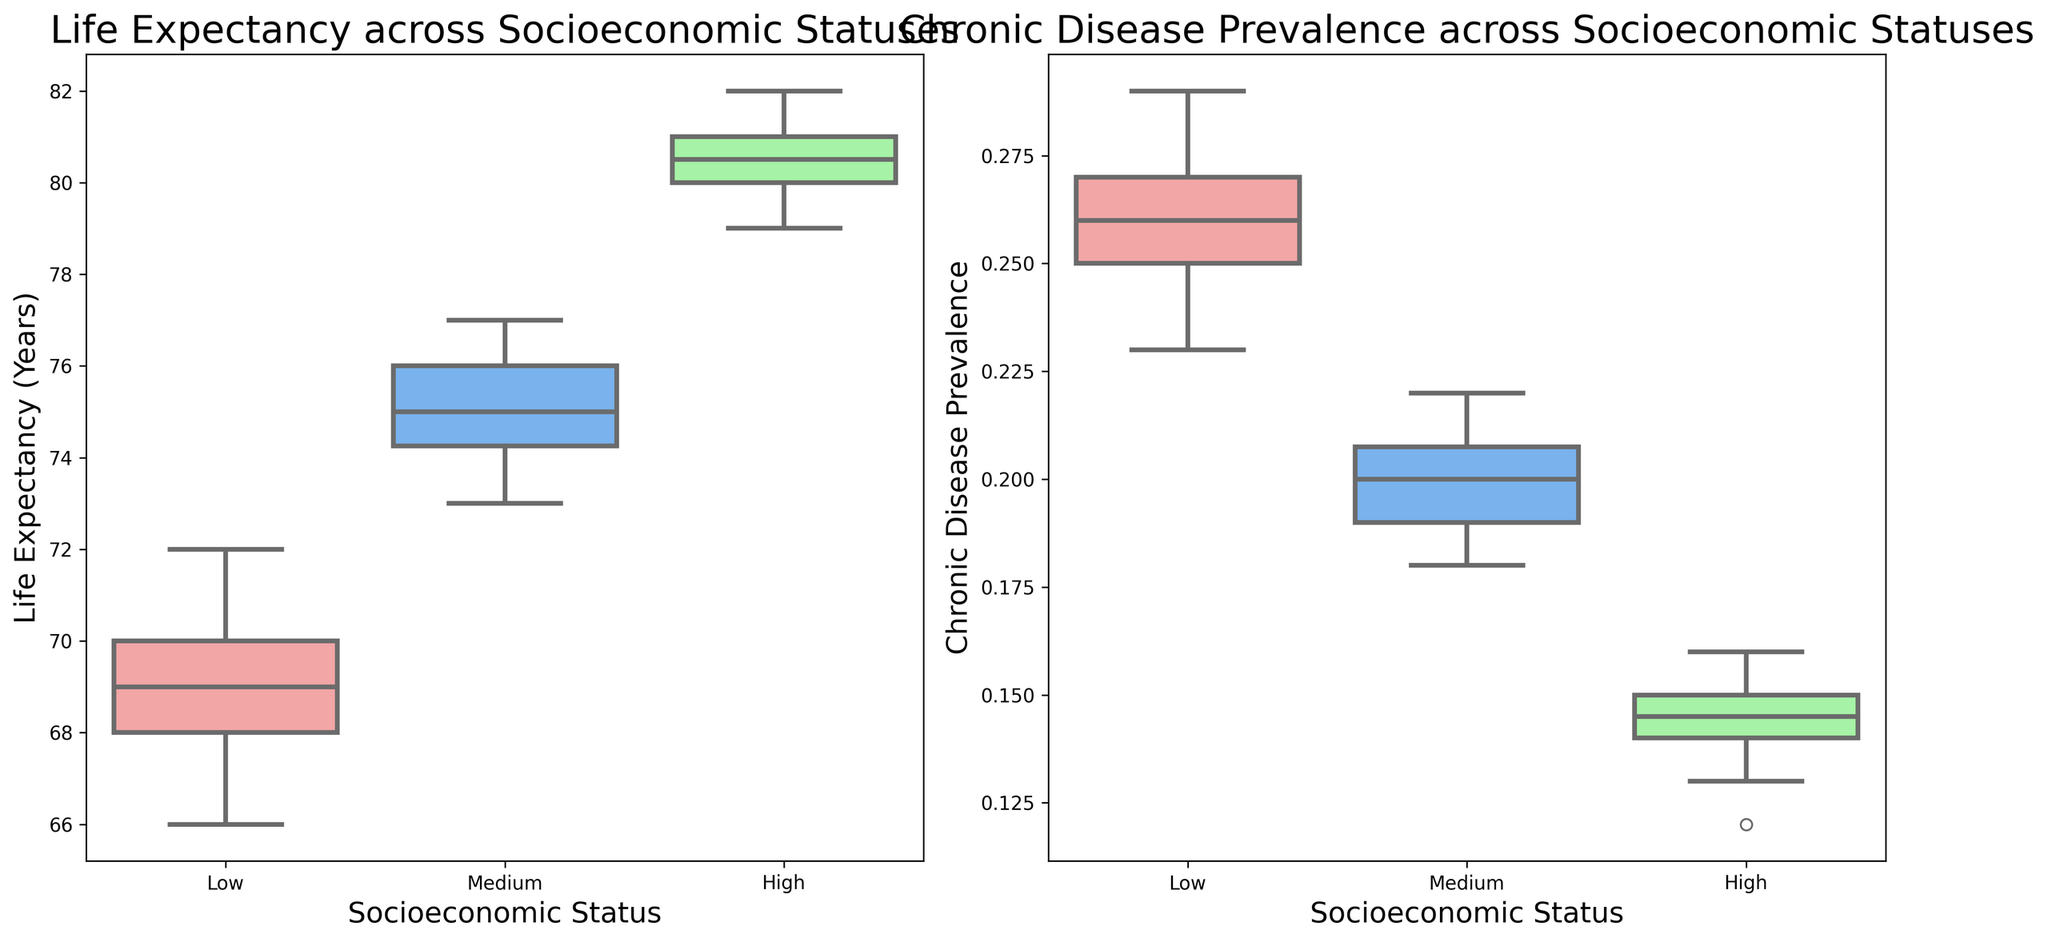What is the median life expectancy for the high socioeconomic status group? The median life expectancy is represented by the line inside the box for the high socioeconomic status group on the left box plot. By examining the plot, you can see this value.
Answer: 80.5 Among the three socioeconomic status groups, which has the highest median life expectancy? By comparing the median lines inside the boxes for each group on the left box plot, identify which group has the highest line. The high socioeconomic status group has the highest median.
Answer: High Which socioeconomic status group has the lowest median chronic disease prevalence, and what is that value? Look at the chronic disease prevalence box plot on the right; the group with the lowest median (line inside the box) represents the lowest chronic disease prevalence. Identify the socioeconomic status and the value.
Answer: High, 0.14 Compare the range of life expectancy between the low and medium socioeconomic status groups. Which has a wider range? The range is measured by the distance between the top and bottom whiskers in the life expectancy box plot. Compare these for the low and medium groups. The low group has the whiskers more spread out, indicating a wider range.
Answer: Low Is the chronic disease prevalence for the medium socioeconomic status group more spread out than the high socioeconomic status group? Evaluate the spread (range) of the boxes and whiskers in the right box plot for the medium and high socioeconomic status groups. The medium group’s spread can be seen as wider compared to the high group's.
Answer: Yes What is the interquartile range (IQR) of life expectancy for the low socioeconomic status group? The IQR is the distance between the first quartile (Q1, bottom of the box) and the third quartile (Q3, top of the box). Locate these values on the life expectancy box plot for the low group and subtract Q1 from Q3.
Answer: 3 years (72 - 69) Approximately what is the highest value of chronic disease prevalence in the medium socioeconomic status group? Identify the top whisker of the box plot for chronic disease prevalence in the medium socioeconomic group, which shows the highest value.
Answer: 0.22 Which group shows the least variability in life expectancy? The group with the smallest height of the box and the shortest whiskers in the life expectancy box plot indicates the least variability. The high socioeconomic status group shows the least variability.
Answer: High Does any socioeconomic status group have outliers in life expectancy or chronic disease prevalence? Outliers are typically represented as individual points beyond the whiskers. Check both box plots for any such points across all groups.
Answer: No How does the chronic disease prevalence of the low socioeconomic status group compare to the high group in terms of median value? Compare the median lines within the boxes of the low and high socioeconomic groups in the chronic disease prevalence box plot. The low group has a higher median prevalence compared to the high group.
Answer: Low group has higher 